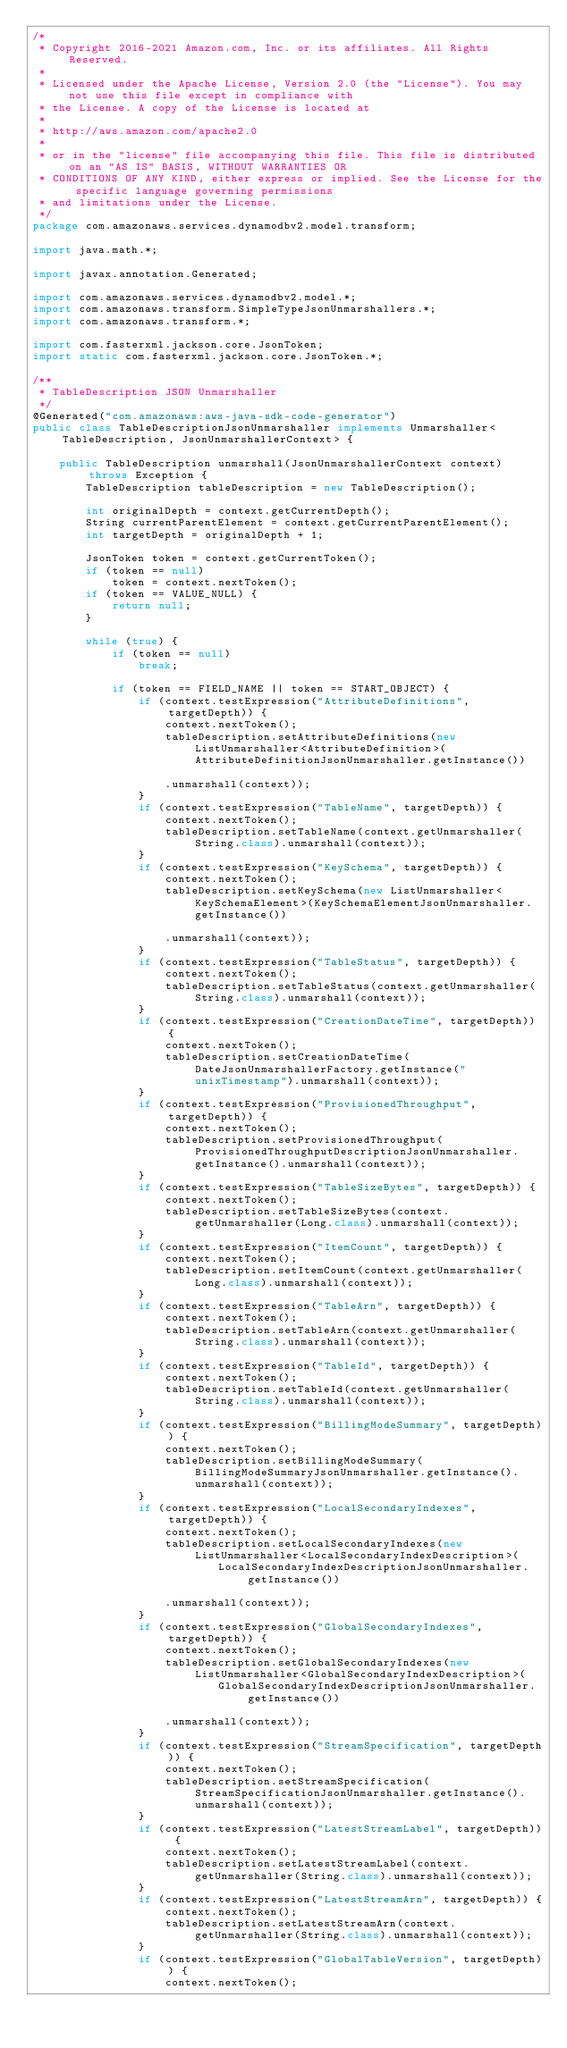<code> <loc_0><loc_0><loc_500><loc_500><_Java_>/*
 * Copyright 2016-2021 Amazon.com, Inc. or its affiliates. All Rights Reserved.
 * 
 * Licensed under the Apache License, Version 2.0 (the "License"). You may not use this file except in compliance with
 * the License. A copy of the License is located at
 * 
 * http://aws.amazon.com/apache2.0
 * 
 * or in the "license" file accompanying this file. This file is distributed on an "AS IS" BASIS, WITHOUT WARRANTIES OR
 * CONDITIONS OF ANY KIND, either express or implied. See the License for the specific language governing permissions
 * and limitations under the License.
 */
package com.amazonaws.services.dynamodbv2.model.transform;

import java.math.*;

import javax.annotation.Generated;

import com.amazonaws.services.dynamodbv2.model.*;
import com.amazonaws.transform.SimpleTypeJsonUnmarshallers.*;
import com.amazonaws.transform.*;

import com.fasterxml.jackson.core.JsonToken;
import static com.fasterxml.jackson.core.JsonToken.*;

/**
 * TableDescription JSON Unmarshaller
 */
@Generated("com.amazonaws:aws-java-sdk-code-generator")
public class TableDescriptionJsonUnmarshaller implements Unmarshaller<TableDescription, JsonUnmarshallerContext> {

    public TableDescription unmarshall(JsonUnmarshallerContext context) throws Exception {
        TableDescription tableDescription = new TableDescription();

        int originalDepth = context.getCurrentDepth();
        String currentParentElement = context.getCurrentParentElement();
        int targetDepth = originalDepth + 1;

        JsonToken token = context.getCurrentToken();
        if (token == null)
            token = context.nextToken();
        if (token == VALUE_NULL) {
            return null;
        }

        while (true) {
            if (token == null)
                break;

            if (token == FIELD_NAME || token == START_OBJECT) {
                if (context.testExpression("AttributeDefinitions", targetDepth)) {
                    context.nextToken();
                    tableDescription.setAttributeDefinitions(new ListUnmarshaller<AttributeDefinition>(AttributeDefinitionJsonUnmarshaller.getInstance())

                    .unmarshall(context));
                }
                if (context.testExpression("TableName", targetDepth)) {
                    context.nextToken();
                    tableDescription.setTableName(context.getUnmarshaller(String.class).unmarshall(context));
                }
                if (context.testExpression("KeySchema", targetDepth)) {
                    context.nextToken();
                    tableDescription.setKeySchema(new ListUnmarshaller<KeySchemaElement>(KeySchemaElementJsonUnmarshaller.getInstance())

                    .unmarshall(context));
                }
                if (context.testExpression("TableStatus", targetDepth)) {
                    context.nextToken();
                    tableDescription.setTableStatus(context.getUnmarshaller(String.class).unmarshall(context));
                }
                if (context.testExpression("CreationDateTime", targetDepth)) {
                    context.nextToken();
                    tableDescription.setCreationDateTime(DateJsonUnmarshallerFactory.getInstance("unixTimestamp").unmarshall(context));
                }
                if (context.testExpression("ProvisionedThroughput", targetDepth)) {
                    context.nextToken();
                    tableDescription.setProvisionedThroughput(ProvisionedThroughputDescriptionJsonUnmarshaller.getInstance().unmarshall(context));
                }
                if (context.testExpression("TableSizeBytes", targetDepth)) {
                    context.nextToken();
                    tableDescription.setTableSizeBytes(context.getUnmarshaller(Long.class).unmarshall(context));
                }
                if (context.testExpression("ItemCount", targetDepth)) {
                    context.nextToken();
                    tableDescription.setItemCount(context.getUnmarshaller(Long.class).unmarshall(context));
                }
                if (context.testExpression("TableArn", targetDepth)) {
                    context.nextToken();
                    tableDescription.setTableArn(context.getUnmarshaller(String.class).unmarshall(context));
                }
                if (context.testExpression("TableId", targetDepth)) {
                    context.nextToken();
                    tableDescription.setTableId(context.getUnmarshaller(String.class).unmarshall(context));
                }
                if (context.testExpression("BillingModeSummary", targetDepth)) {
                    context.nextToken();
                    tableDescription.setBillingModeSummary(BillingModeSummaryJsonUnmarshaller.getInstance().unmarshall(context));
                }
                if (context.testExpression("LocalSecondaryIndexes", targetDepth)) {
                    context.nextToken();
                    tableDescription.setLocalSecondaryIndexes(new ListUnmarshaller<LocalSecondaryIndexDescription>(
                            LocalSecondaryIndexDescriptionJsonUnmarshaller.getInstance())

                    .unmarshall(context));
                }
                if (context.testExpression("GlobalSecondaryIndexes", targetDepth)) {
                    context.nextToken();
                    tableDescription.setGlobalSecondaryIndexes(new ListUnmarshaller<GlobalSecondaryIndexDescription>(
                            GlobalSecondaryIndexDescriptionJsonUnmarshaller.getInstance())

                    .unmarshall(context));
                }
                if (context.testExpression("StreamSpecification", targetDepth)) {
                    context.nextToken();
                    tableDescription.setStreamSpecification(StreamSpecificationJsonUnmarshaller.getInstance().unmarshall(context));
                }
                if (context.testExpression("LatestStreamLabel", targetDepth)) {
                    context.nextToken();
                    tableDescription.setLatestStreamLabel(context.getUnmarshaller(String.class).unmarshall(context));
                }
                if (context.testExpression("LatestStreamArn", targetDepth)) {
                    context.nextToken();
                    tableDescription.setLatestStreamArn(context.getUnmarshaller(String.class).unmarshall(context));
                }
                if (context.testExpression("GlobalTableVersion", targetDepth)) {
                    context.nextToken();</code> 